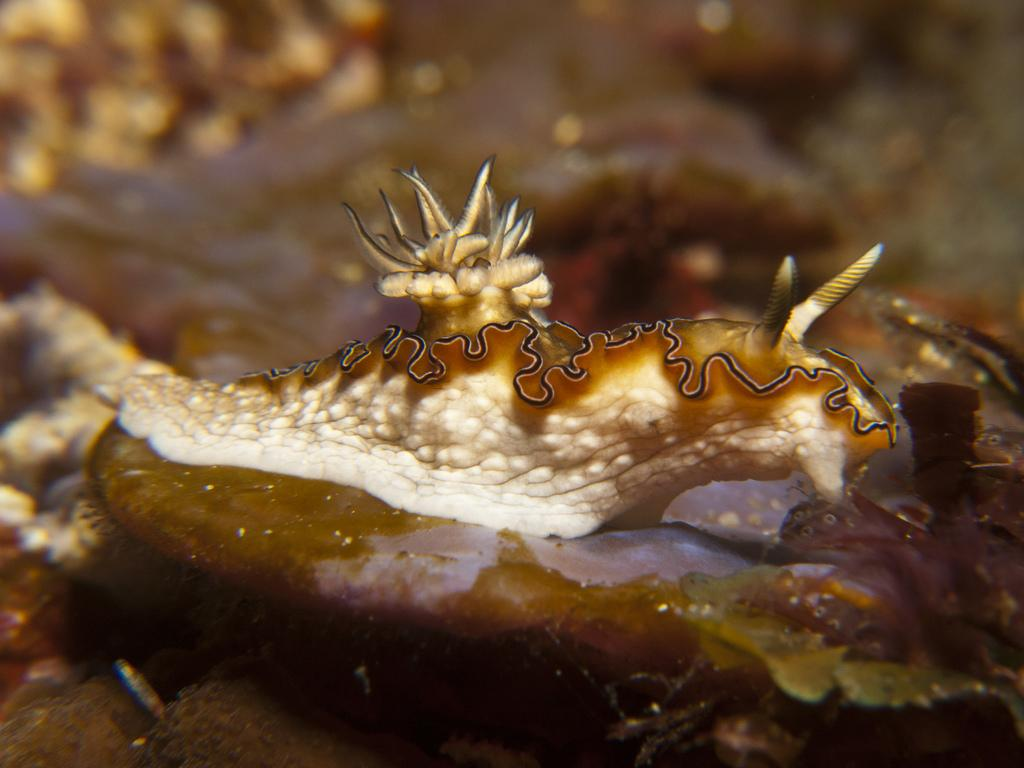What type of natural feature can be seen in the image? There is a water body in the image. What kind of marine creature is present in the image? There is a sea slug in the image. What type of apple can be seen floating in the water body in the image? There is no apple present in the image; it only features a water body and a sea slug. How does the sea slug use its nose to navigate in the water body in the image? Sea slugs do not have noses, so they cannot use them to navigate in the water body. 